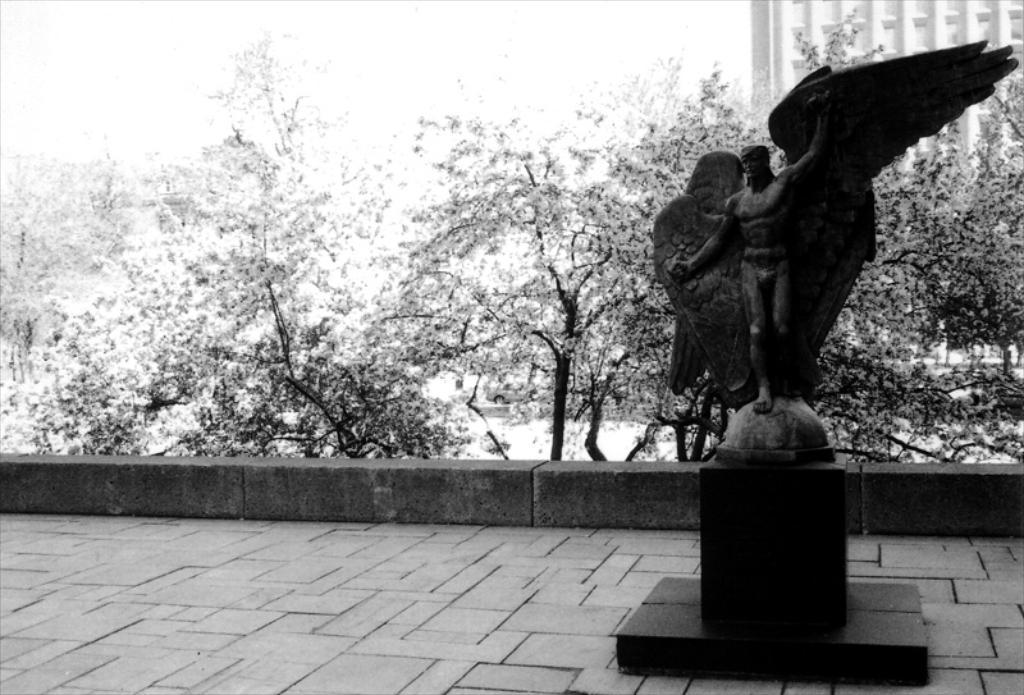Can you describe this image briefly? In the right there is a statue of a person and wings are visible. In the middle there are trees are visible and on the top right building is visible and on the top sky white in color is visible. In the middle wall fence is visible. This image is taken during day time. 